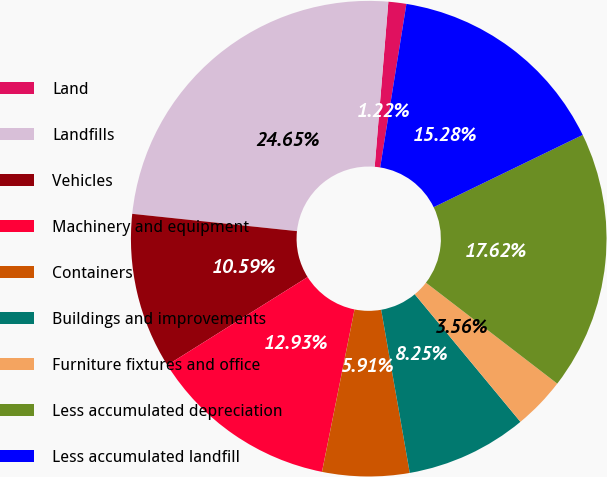<chart> <loc_0><loc_0><loc_500><loc_500><pie_chart><fcel>Land<fcel>Landfills<fcel>Vehicles<fcel>Machinery and equipment<fcel>Containers<fcel>Buildings and improvements<fcel>Furniture fixtures and office<fcel>Less accumulated depreciation<fcel>Less accumulated landfill<nl><fcel>1.22%<fcel>24.65%<fcel>10.59%<fcel>12.93%<fcel>5.91%<fcel>8.25%<fcel>3.56%<fcel>17.62%<fcel>15.28%<nl></chart> 